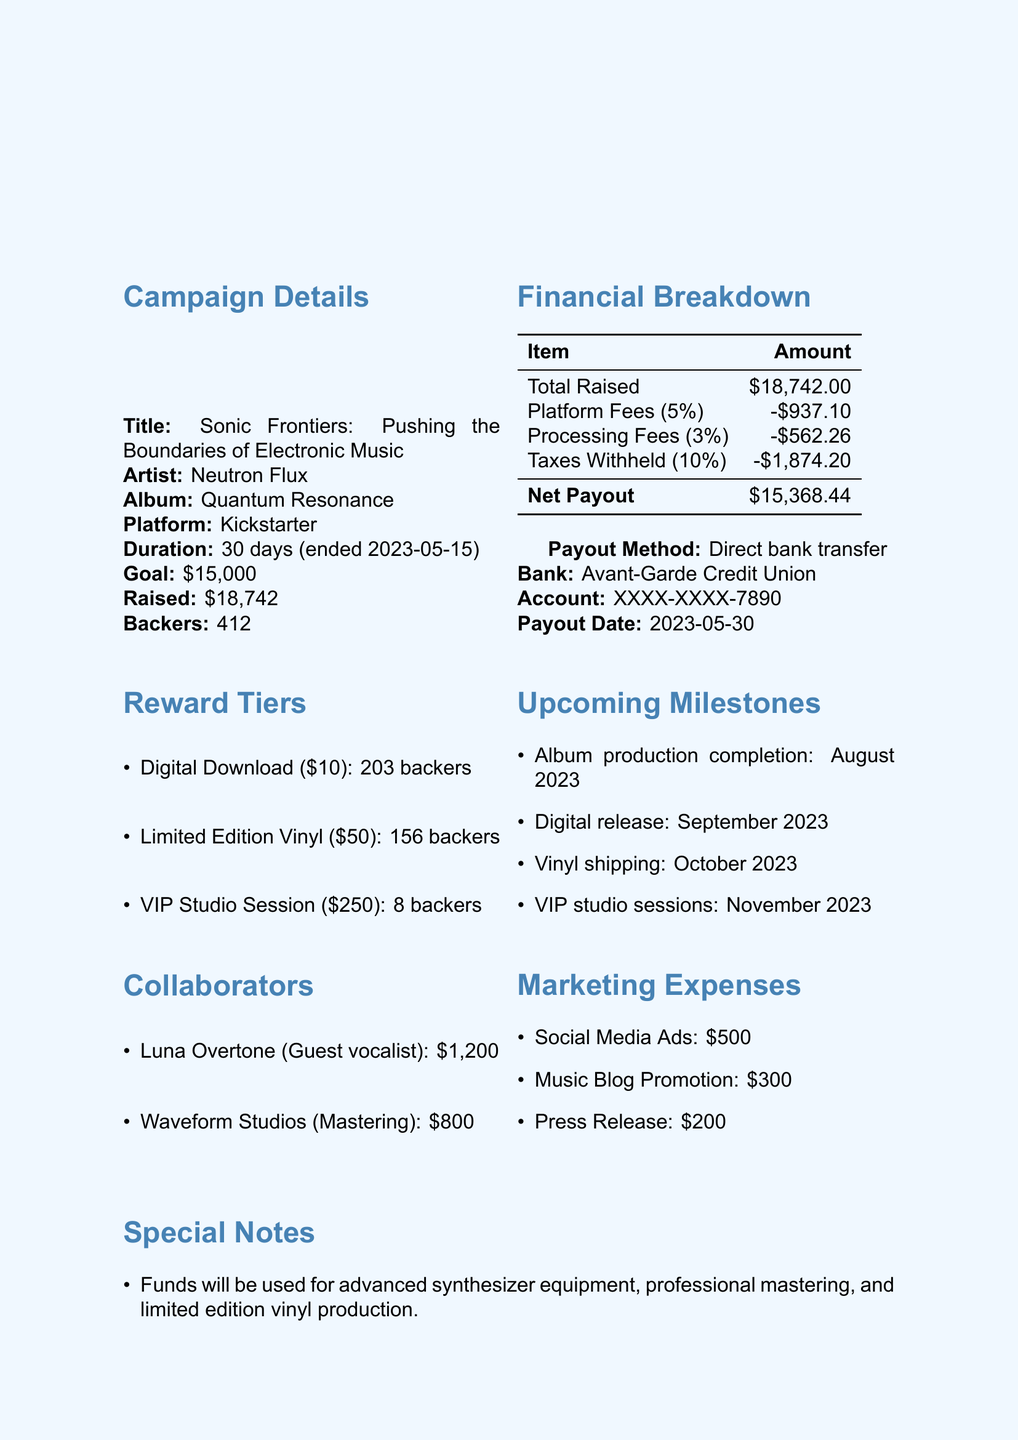what is the campaign title? The campaign title is included in the document's details under Campaign Details section.
Answer: Sonic Frontiers: Pushing the Boundaries of Electronic Music who is the artist? The document provides the artist's name in the Campaign Details section.
Answer: Neutron Flux what is the total funds raised? The total funds raised is explicitly stated in the Financial Breakdown section of the document.
Answer: $18,742 what is the payout date? The payout date is listed under the Financial Breakdown section as well.
Answer: 2023-05-30 how many backers contributed to the Digital Download tier? This information is provided in the Reward Tiers section, specifying the number of backers for each tier.
Answer: 203 what is the total amount of taxes withheld? The taxes withheld amount can be found in the Financial Breakdown section.
Answer: $1,874.20 what percentage is taken as platform fees? The platform fees percentage is detailed in the Financial Breakdown section of the document.
Answer: 5% how much is allocated for marketing expenses in total? The total marketing expenses can be calculated by summing the amounts listed for each marketing category in the Marketing Expenses section.
Answer: $1,000 what is the payout method? The payout method is specified under the Financial Breakdown section, indicating how the funds will be transferred.
Answer: Direct bank transfer 